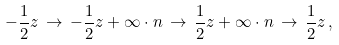Convert formula to latex. <formula><loc_0><loc_0><loc_500><loc_500>- \frac { 1 } { 2 } z \, \to \, - \frac { 1 } { 2 } z + \infty \cdot n \, \to \, \frac { 1 } { 2 } z + \infty \cdot n \, \to \, \frac { 1 } { 2 } z \, ,</formula> 